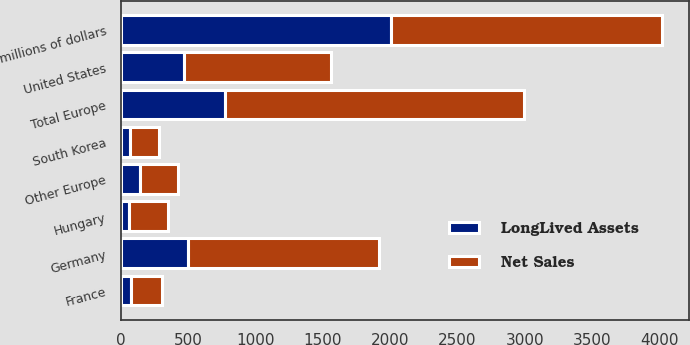Convert chart. <chart><loc_0><loc_0><loc_500><loc_500><stacked_bar_chart><ecel><fcel>millions of dollars<fcel>United States<fcel>Germany<fcel>Hungary<fcel>France<fcel>Other Europe<fcel>Total Europe<fcel>South Korea<nl><fcel>Net Sales<fcel>2009<fcel>1090.4<fcel>1419.9<fcel>292.4<fcel>229.5<fcel>282.9<fcel>2224.7<fcel>212.4<nl><fcel>LongLived Assets<fcel>2009<fcel>469.4<fcel>500<fcel>58.4<fcel>72.9<fcel>138.1<fcel>769.4<fcel>69.1<nl></chart> 